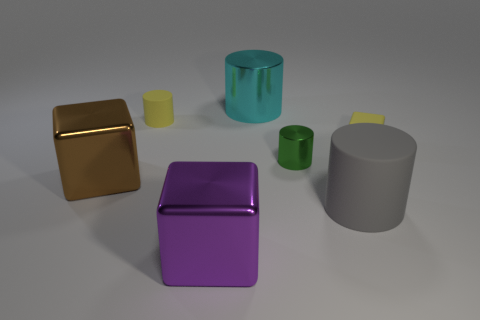The matte cylinder that is in front of the metallic cylinder that is to the right of the metallic cylinder that is behind the tiny yellow cylinder is what color?
Make the answer very short. Gray. What number of cylinders are either large red rubber things or large purple shiny objects?
Ensure brevity in your answer.  0. There is a thing that is the same color as the rubber block; what is it made of?
Give a very brief answer. Rubber. Do the large metallic cylinder and the small cylinder in front of the rubber cube have the same color?
Your answer should be compact. No. What color is the large matte cylinder?
Provide a short and direct response. Gray. What number of objects are large yellow blocks or small cylinders?
Offer a very short reply. 2. There is a gray object that is the same size as the cyan metal thing; what is it made of?
Your answer should be compact. Rubber. There is a thing in front of the gray cylinder; how big is it?
Make the answer very short. Large. What is the material of the tiny block?
Offer a terse response. Rubber. How many things are things in front of the brown cube or things that are on the right side of the brown metal thing?
Your response must be concise. 6. 